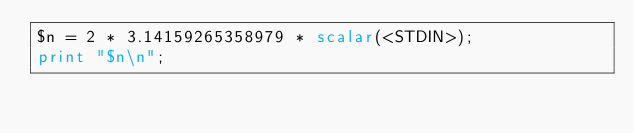Convert code to text. <code><loc_0><loc_0><loc_500><loc_500><_Perl_>$n = 2 * 3.14159265358979 * scalar(<STDIN>);
print "$n\n";
</code> 